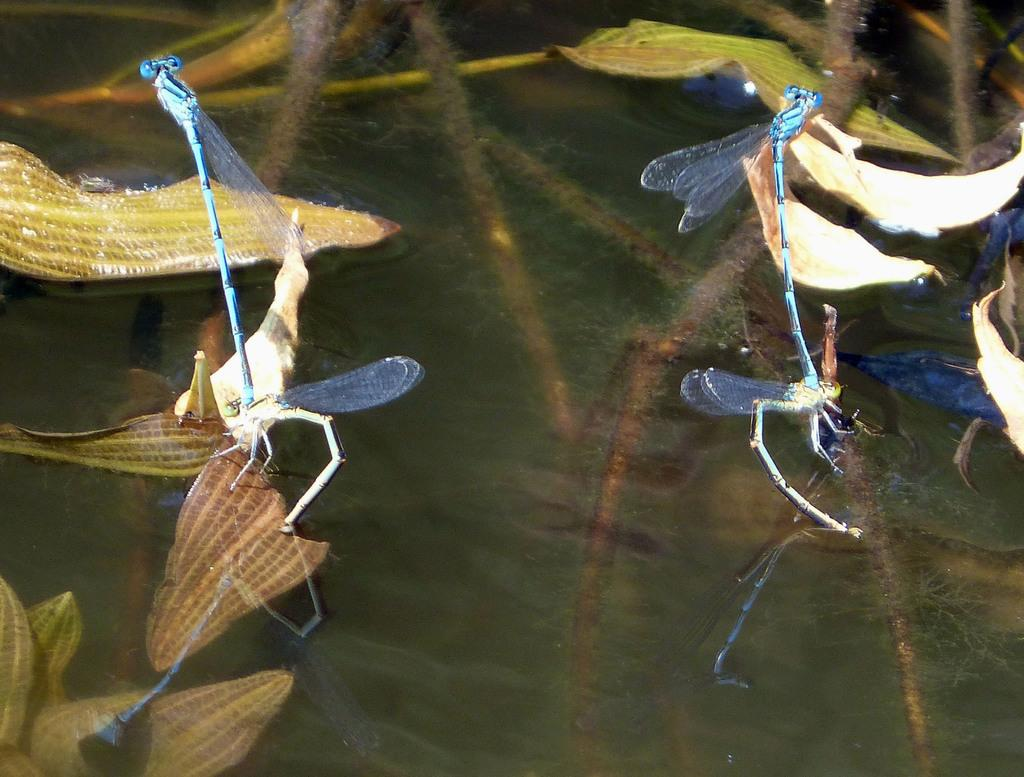What is the main feature of the image? There is a pond in the image. What can be found in the pond? There are insects and water plants in the pond. What type of scent can be detected from the glass pipe in the image? There is no glass pipe present in the image, so it is not possible to detect any scent from it. 